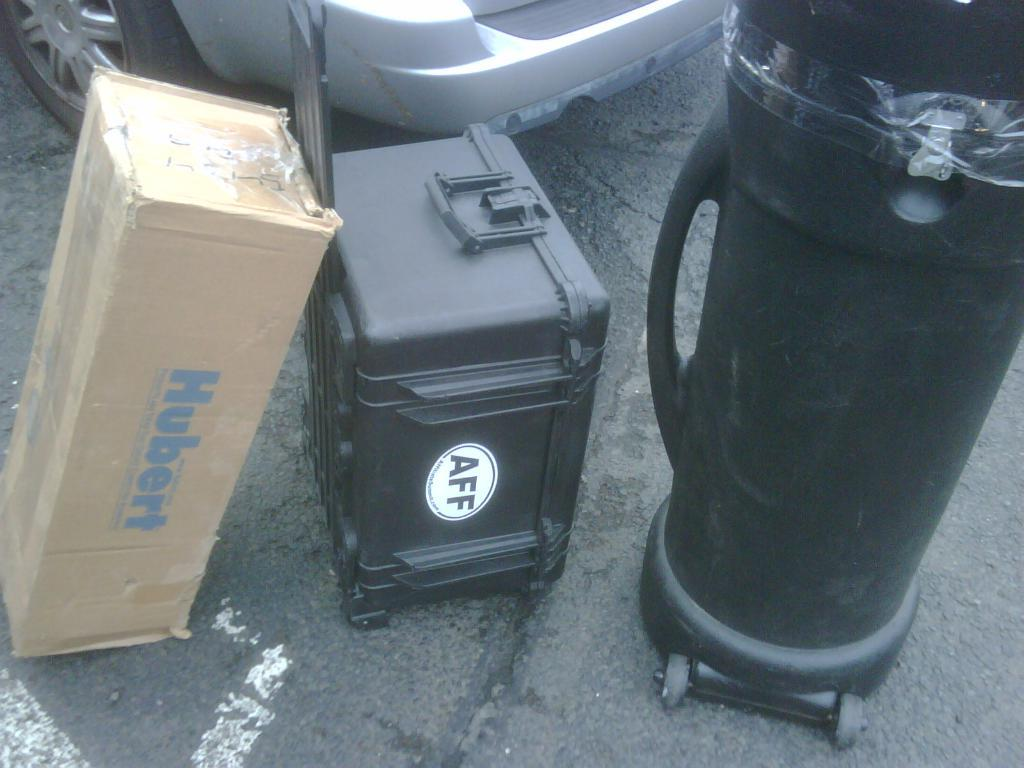<image>
Relay a brief, clear account of the picture shown. A box labeled Hubert sits beside a different sized luggage. 